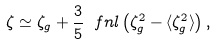<formula> <loc_0><loc_0><loc_500><loc_500>\zeta \simeq \zeta _ { g } + \frac { 3 } { 5 } \ f n l \left ( \zeta _ { g } ^ { 2 } - \langle \zeta _ { g } ^ { 2 } \rangle \right ) ,</formula> 